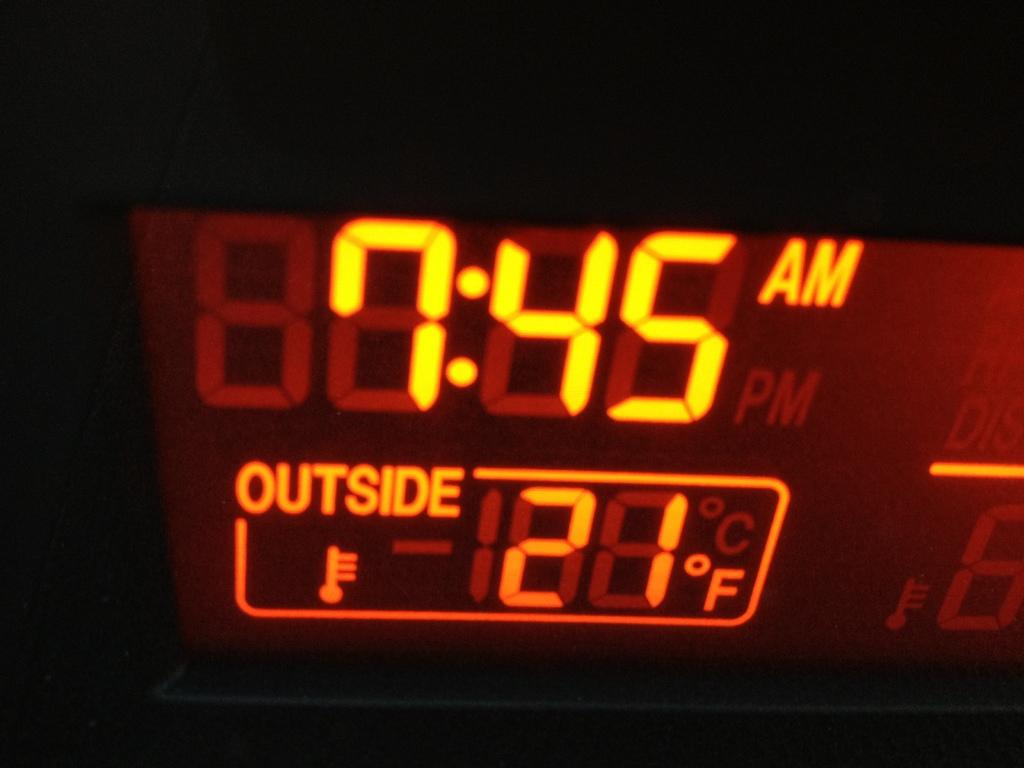What type of setting is depicted in the image? The image is an inside view of a vehicle. Can you describe the time of day in the image? The image was taken during nighttime. What type of print can be seen on the car's exterior in the image? There is no car exterior visible in the image, as it is an inside view of a vehicle. 